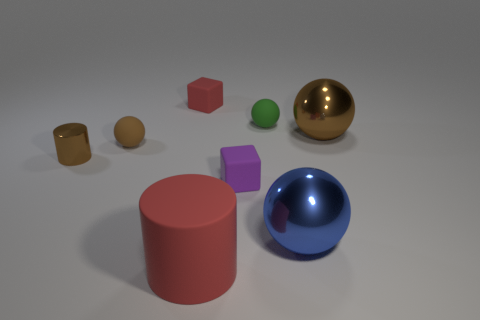There is a shiny object that is behind the small purple matte thing and to the right of the big red rubber cylinder; how big is it?
Your response must be concise. Large. How many cylinders are either small metal things or shiny things?
Your answer should be compact. 1. What is the color of the rubber cube that is the same size as the purple rubber thing?
Provide a succinct answer. Red. There is another big thing that is the same shape as the large blue shiny object; what is its color?
Offer a very short reply. Brown. What number of things are red blocks or blocks behind the small brown cylinder?
Your answer should be very brief. 1. Are there fewer large shiny things that are in front of the purple rubber thing than big gray balls?
Make the answer very short. No. There is a metallic object in front of the small cube that is in front of the red rubber cube left of the purple thing; what is its size?
Your answer should be very brief. Large. What color is the thing that is both in front of the purple block and left of the tiny purple cube?
Provide a succinct answer. Red. What number of small red matte cylinders are there?
Your answer should be very brief. 0. Do the small red block and the large red object have the same material?
Offer a terse response. Yes. 